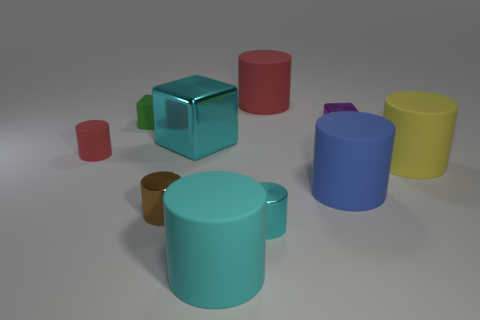How big is the red rubber thing that is left of the big matte thing that is behind the yellow thing?
Offer a very short reply. Small. There is a cylinder that is to the left of the rubber cube that is on the left side of the large matte cylinder that is behind the yellow rubber object; how big is it?
Your answer should be very brief. Small. There is a big cyan thing that is behind the red cylinder in front of the red matte cylinder right of the small green object; what is it made of?
Give a very brief answer. Metal. Does the small green thing have the same shape as the yellow rubber object?
Your answer should be very brief. No. How many large things are both behind the large yellow cylinder and on the right side of the cyan metallic cylinder?
Ensure brevity in your answer.  1. The tiny cube to the right of the shiny cylinder that is right of the tiny brown object is what color?
Provide a succinct answer. Purple. What number of cyan shiny things are in front of the metallic thing that is in front of the brown metal thing that is to the left of the cyan rubber object?
Provide a succinct answer. 0. There is a tiny thing to the right of the big red thing; what is its color?
Your answer should be compact. Purple. What is the cylinder that is both behind the yellow thing and on the right side of the tiny red cylinder made of?
Give a very brief answer. Rubber. How many large red matte cylinders are left of the red cylinder on the right side of the big cyan rubber thing?
Give a very brief answer. 0. 